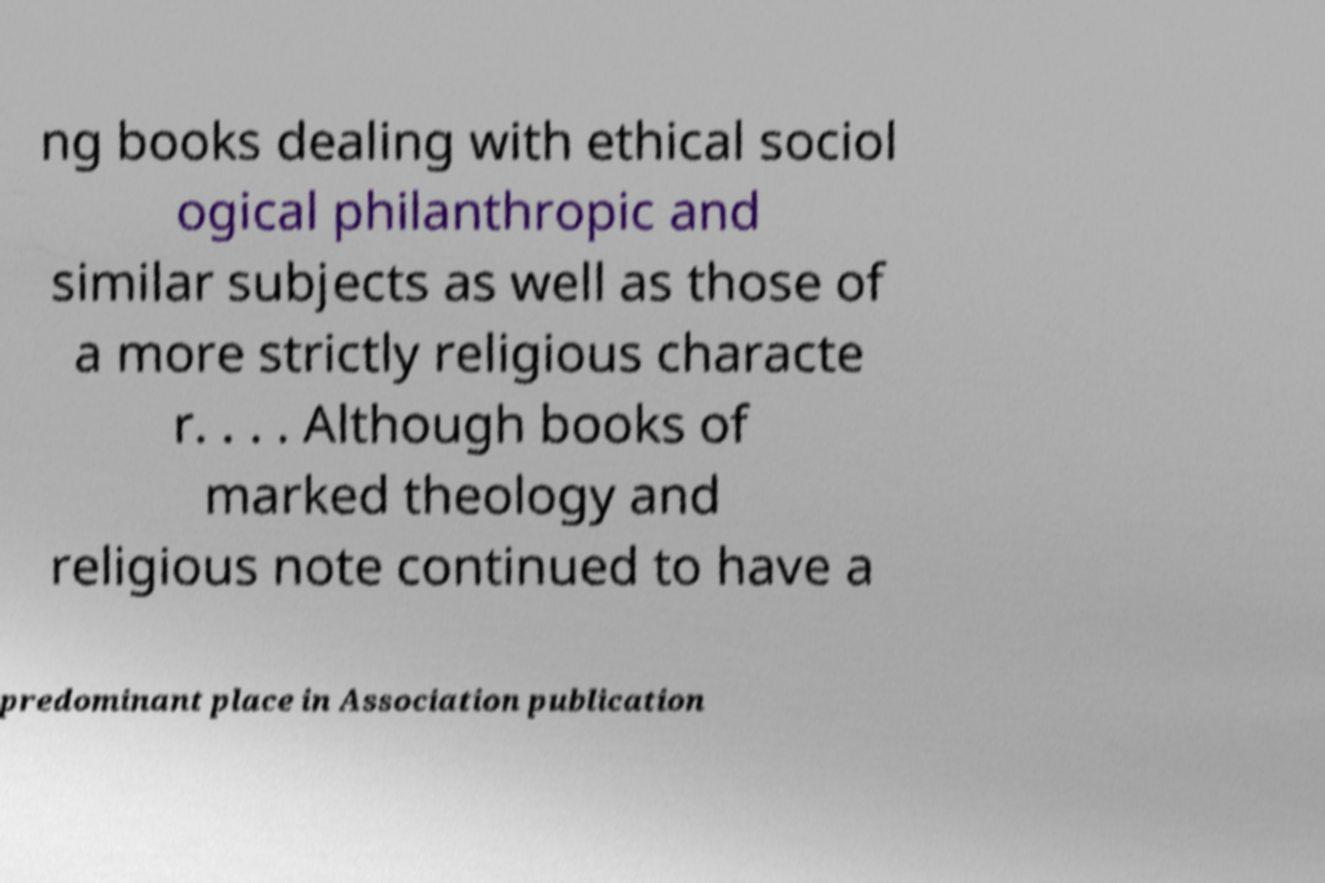What messages or text are displayed in this image? I need them in a readable, typed format. ng books dealing with ethical sociol ogical philanthropic and similar subjects as well as those of a more strictly religious characte r. . . . Although books of marked theology and religious note continued to have a predominant place in Association publication 